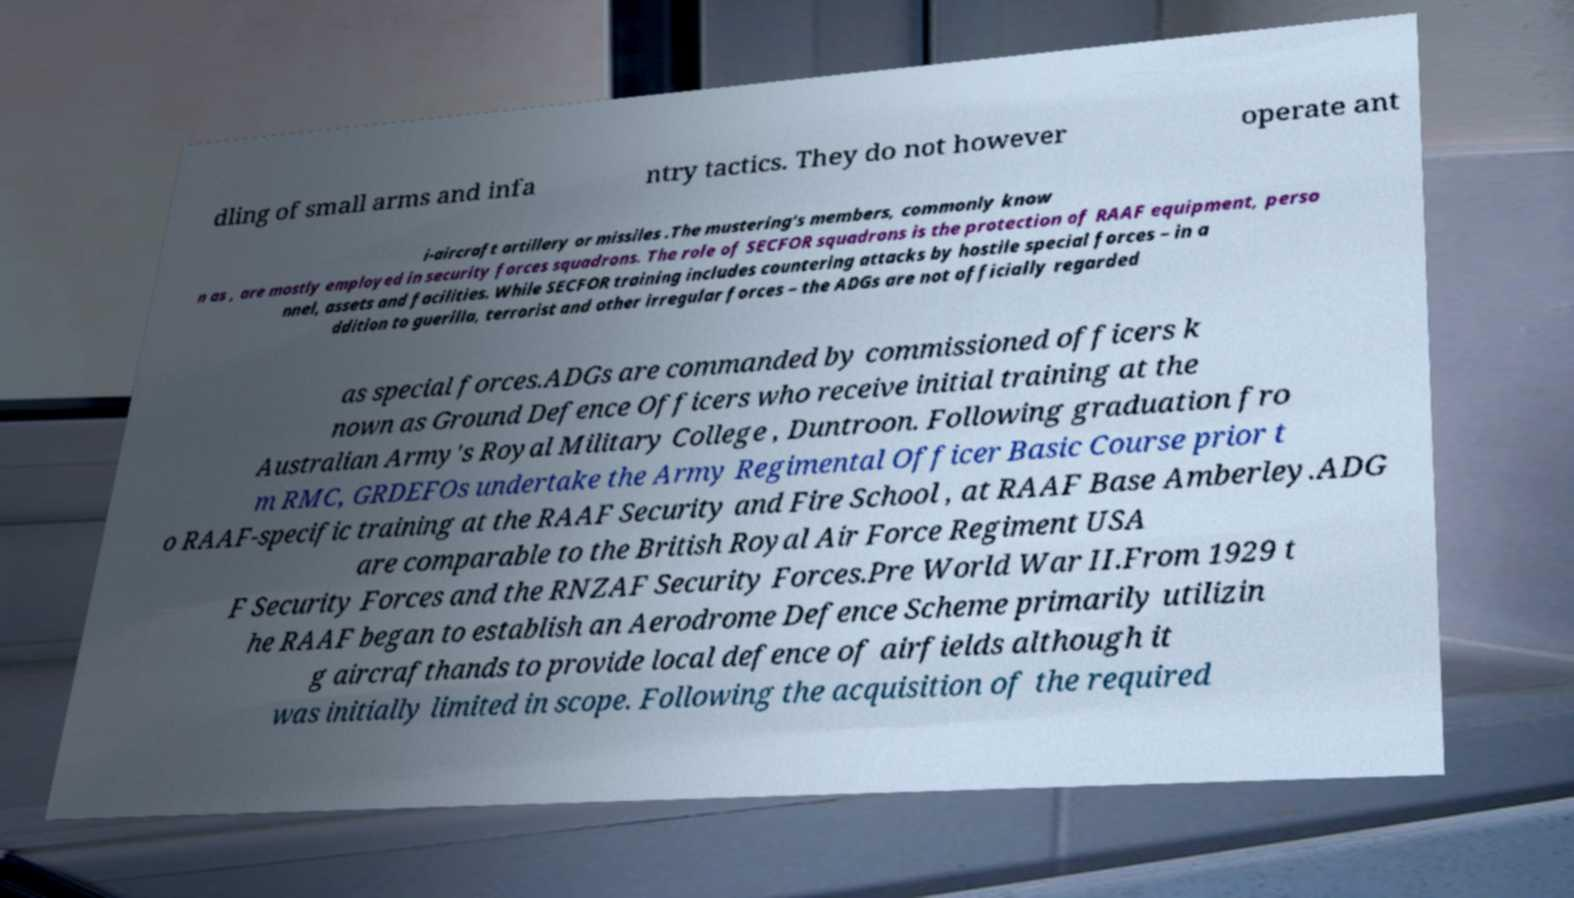I need the written content from this picture converted into text. Can you do that? dling of small arms and infa ntry tactics. They do not however operate ant i-aircraft artillery or missiles .The mustering's members, commonly know n as , are mostly employed in security forces squadrons. The role of SECFOR squadrons is the protection of RAAF equipment, perso nnel, assets and facilities. While SECFOR training includes countering attacks by hostile special forces – in a ddition to guerilla, terrorist and other irregular forces – the ADGs are not officially regarded as special forces.ADGs are commanded by commissioned officers k nown as Ground Defence Officers who receive initial training at the Australian Army's Royal Military College , Duntroon. Following graduation fro m RMC, GRDEFOs undertake the Army Regimental Officer Basic Course prior t o RAAF-specific training at the RAAF Security and Fire School , at RAAF Base Amberley.ADG are comparable to the British Royal Air Force Regiment USA F Security Forces and the RNZAF Security Forces.Pre World War II.From 1929 t he RAAF began to establish an Aerodrome Defence Scheme primarily utilizin g aircrafthands to provide local defence of airfields although it was initially limited in scope. Following the acquisition of the required 